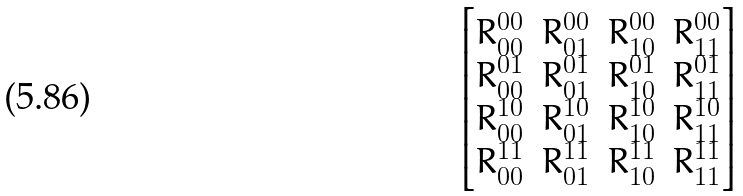<formula> <loc_0><loc_0><loc_500><loc_500>\begin{bmatrix} R _ { 0 0 } ^ { 0 0 } & R _ { 0 1 } ^ { 0 0 } & R _ { 1 0 } ^ { 0 0 } & R _ { 1 1 } ^ { 0 0 } \\ R _ { 0 0 } ^ { 0 1 } & R _ { 0 1 } ^ { 0 1 } & R _ { 1 0 } ^ { 0 1 } & R _ { 1 1 } ^ { 0 1 } \\ R _ { 0 0 } ^ { 1 0 } & R _ { 0 1 } ^ { 1 0 } & R _ { 1 0 } ^ { 1 0 } & R _ { 1 1 } ^ { 1 0 } \\ R _ { 0 0 } ^ { 1 1 } & R _ { 0 1 } ^ { 1 1 } & R _ { 1 0 } ^ { 1 1 } & R _ { 1 1 } ^ { 1 1 } \end{bmatrix}</formula> 